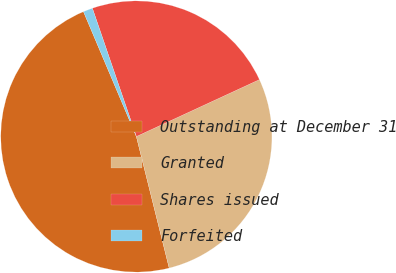Convert chart. <chart><loc_0><loc_0><loc_500><loc_500><pie_chart><fcel>Outstanding at December 31<fcel>Granted<fcel>Shares issued<fcel>Forfeited<nl><fcel>47.51%<fcel>28.0%<fcel>23.36%<fcel>1.12%<nl></chart> 